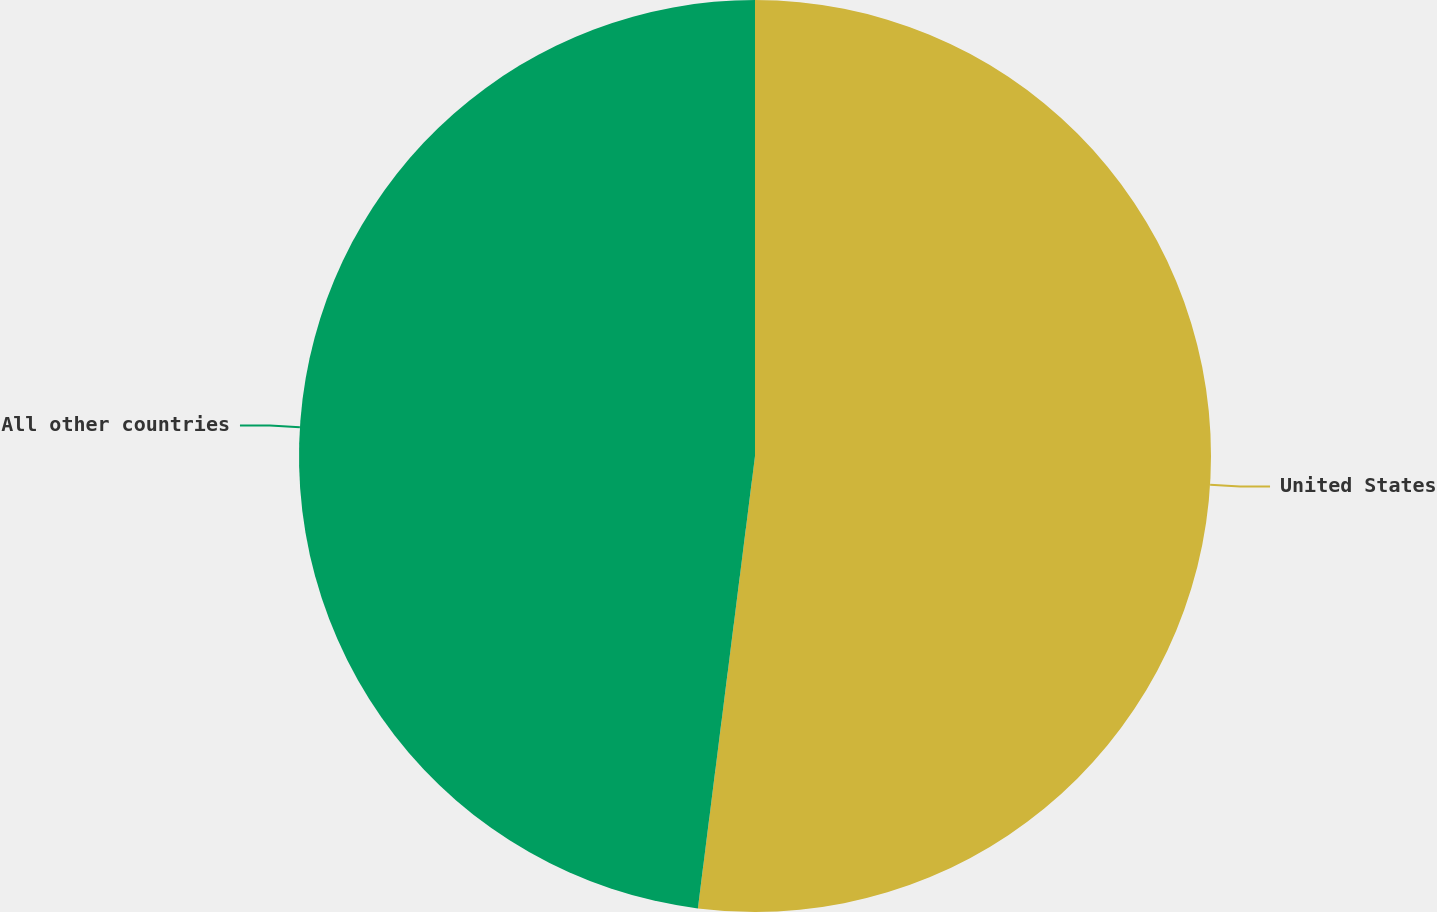<chart> <loc_0><loc_0><loc_500><loc_500><pie_chart><fcel>United States<fcel>All other countries<nl><fcel>52.0%<fcel>48.0%<nl></chart> 